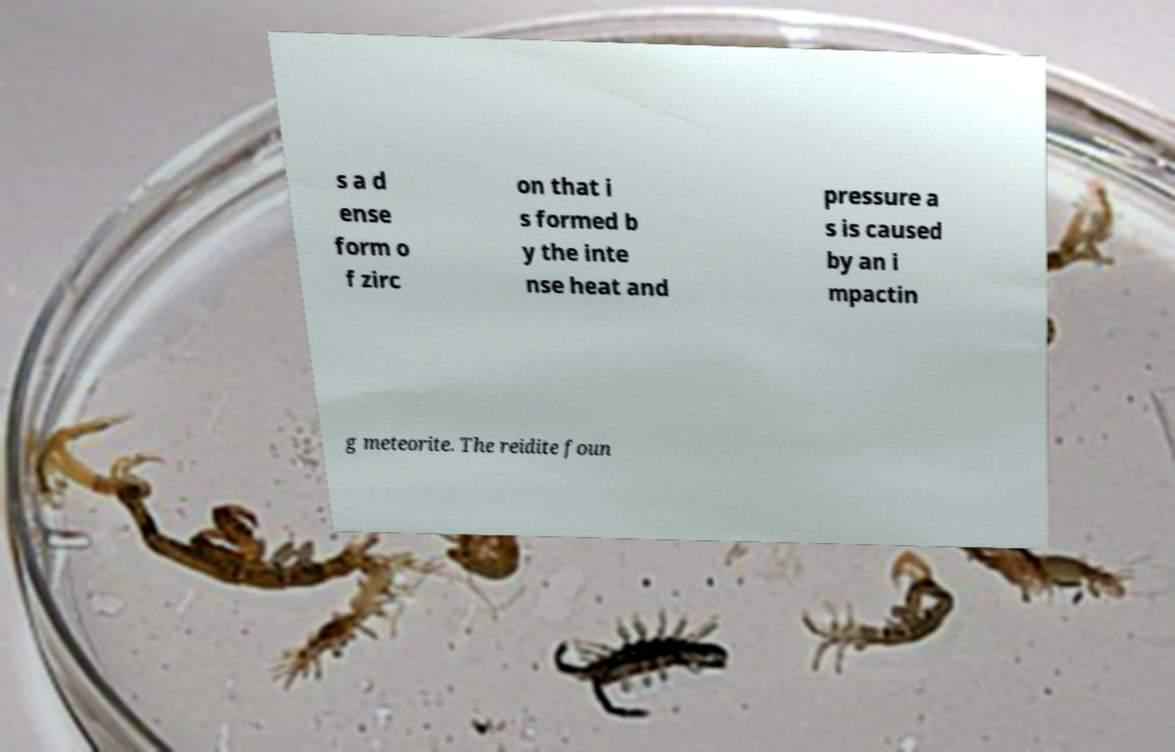Could you assist in decoding the text presented in this image and type it out clearly? s a d ense form o f zirc on that i s formed b y the inte nse heat and pressure a s is caused by an i mpactin g meteorite. The reidite foun 